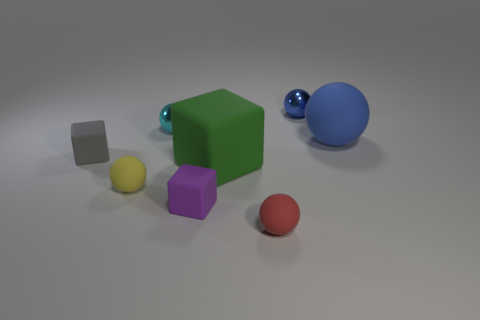Subtract all cyan spheres. How many spheres are left? 4 Subtract all large matte spheres. How many spheres are left? 4 Subtract 1 spheres. How many spheres are left? 4 Subtract all brown balls. Subtract all gray cylinders. How many balls are left? 5 Add 2 small balls. How many objects exist? 10 Subtract all spheres. How many objects are left? 3 Subtract all cyan things. Subtract all cyan balls. How many objects are left? 6 Add 7 purple rubber objects. How many purple rubber objects are left? 8 Add 8 big brown cubes. How many big brown cubes exist? 8 Subtract 0 blue cylinders. How many objects are left? 8 